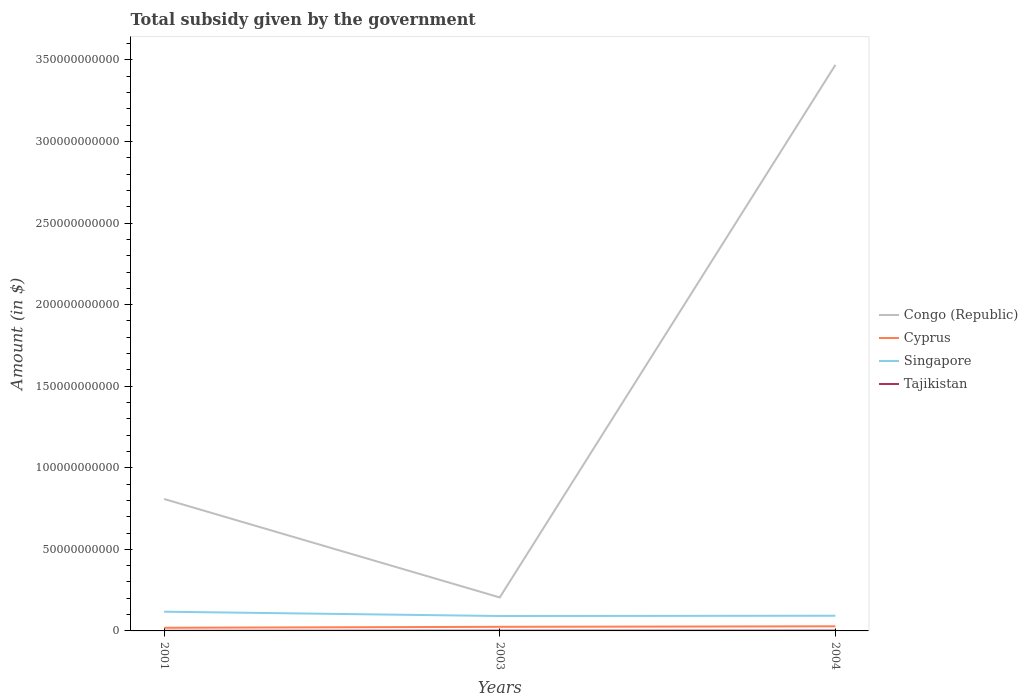How many different coloured lines are there?
Offer a terse response. 4. Does the line corresponding to Singapore intersect with the line corresponding to Tajikistan?
Your answer should be compact. No. Is the number of lines equal to the number of legend labels?
Ensure brevity in your answer.  Yes. Across all years, what is the maximum total revenue collected by the government in Congo (Republic)?
Give a very brief answer. 2.05e+1. In which year was the total revenue collected by the government in Singapore maximum?
Make the answer very short. 2003. What is the total total revenue collected by the government in Singapore in the graph?
Give a very brief answer. 2.47e+09. What is the difference between the highest and the second highest total revenue collected by the government in Cyprus?
Your response must be concise. 9.10e+08. How many lines are there?
Your response must be concise. 4. How many years are there in the graph?
Your answer should be compact. 3. What is the difference between two consecutive major ticks on the Y-axis?
Offer a very short reply. 5.00e+1. Are the values on the major ticks of Y-axis written in scientific E-notation?
Provide a succinct answer. No. Does the graph contain grids?
Ensure brevity in your answer.  No. How are the legend labels stacked?
Provide a short and direct response. Vertical. What is the title of the graph?
Your answer should be compact. Total subsidy given by the government. Does "Costa Rica" appear as one of the legend labels in the graph?
Your response must be concise. No. What is the label or title of the Y-axis?
Provide a succinct answer. Amount (in $). What is the Amount (in $) of Congo (Republic) in 2001?
Give a very brief answer. 8.09e+1. What is the Amount (in $) in Cyprus in 2001?
Keep it short and to the point. 1.92e+09. What is the Amount (in $) in Singapore in 2001?
Make the answer very short. 1.18e+1. What is the Amount (in $) in Tajikistan in 2001?
Give a very brief answer. 1.01e+08. What is the Amount (in $) of Congo (Republic) in 2003?
Offer a terse response. 2.05e+1. What is the Amount (in $) of Cyprus in 2003?
Make the answer very short. 2.52e+09. What is the Amount (in $) of Singapore in 2003?
Your answer should be compact. 9.13e+09. What is the Amount (in $) in Tajikistan in 2003?
Your answer should be very brief. 1.81e+08. What is the Amount (in $) of Congo (Republic) in 2004?
Offer a terse response. 3.47e+11. What is the Amount (in $) of Cyprus in 2004?
Your response must be concise. 2.83e+09. What is the Amount (in $) in Singapore in 2004?
Make the answer very short. 9.31e+09. What is the Amount (in $) in Tajikistan in 2004?
Give a very brief answer. 2.29e+08. Across all years, what is the maximum Amount (in $) in Congo (Republic)?
Provide a short and direct response. 3.47e+11. Across all years, what is the maximum Amount (in $) in Cyprus?
Your answer should be compact. 2.83e+09. Across all years, what is the maximum Amount (in $) of Singapore?
Make the answer very short. 1.18e+1. Across all years, what is the maximum Amount (in $) in Tajikistan?
Keep it short and to the point. 2.29e+08. Across all years, what is the minimum Amount (in $) in Congo (Republic)?
Your answer should be very brief. 2.05e+1. Across all years, what is the minimum Amount (in $) in Cyprus?
Your response must be concise. 1.92e+09. Across all years, what is the minimum Amount (in $) of Singapore?
Keep it short and to the point. 9.13e+09. Across all years, what is the minimum Amount (in $) in Tajikistan?
Provide a succinct answer. 1.01e+08. What is the total Amount (in $) in Congo (Republic) in the graph?
Keep it short and to the point. 4.48e+11. What is the total Amount (in $) in Cyprus in the graph?
Offer a very short reply. 7.28e+09. What is the total Amount (in $) of Singapore in the graph?
Give a very brief answer. 3.02e+1. What is the total Amount (in $) in Tajikistan in the graph?
Provide a succinct answer. 5.11e+08. What is the difference between the Amount (in $) of Congo (Republic) in 2001 and that in 2003?
Offer a very short reply. 6.04e+1. What is the difference between the Amount (in $) in Cyprus in 2001 and that in 2003?
Your answer should be compact. -5.96e+08. What is the difference between the Amount (in $) in Singapore in 2001 and that in 2003?
Your answer should be very brief. 2.65e+09. What is the difference between the Amount (in $) in Tajikistan in 2001 and that in 2003?
Your answer should be very brief. -8.01e+07. What is the difference between the Amount (in $) in Congo (Republic) in 2001 and that in 2004?
Give a very brief answer. -2.66e+11. What is the difference between the Amount (in $) of Cyprus in 2001 and that in 2004?
Provide a succinct answer. -9.10e+08. What is the difference between the Amount (in $) of Singapore in 2001 and that in 2004?
Give a very brief answer. 2.47e+09. What is the difference between the Amount (in $) of Tajikistan in 2001 and that in 2004?
Your answer should be compact. -1.28e+08. What is the difference between the Amount (in $) in Congo (Republic) in 2003 and that in 2004?
Provide a succinct answer. -3.26e+11. What is the difference between the Amount (in $) in Cyprus in 2003 and that in 2004?
Your answer should be very brief. -3.14e+08. What is the difference between the Amount (in $) in Singapore in 2003 and that in 2004?
Give a very brief answer. -1.80e+08. What is the difference between the Amount (in $) in Tajikistan in 2003 and that in 2004?
Offer a terse response. -4.79e+07. What is the difference between the Amount (in $) in Congo (Republic) in 2001 and the Amount (in $) in Cyprus in 2003?
Your response must be concise. 7.84e+1. What is the difference between the Amount (in $) of Congo (Republic) in 2001 and the Amount (in $) of Singapore in 2003?
Your response must be concise. 7.17e+1. What is the difference between the Amount (in $) in Congo (Republic) in 2001 and the Amount (in $) in Tajikistan in 2003?
Provide a short and direct response. 8.07e+1. What is the difference between the Amount (in $) in Cyprus in 2001 and the Amount (in $) in Singapore in 2003?
Keep it short and to the point. -7.21e+09. What is the difference between the Amount (in $) of Cyprus in 2001 and the Amount (in $) of Tajikistan in 2003?
Ensure brevity in your answer.  1.74e+09. What is the difference between the Amount (in $) of Singapore in 2001 and the Amount (in $) of Tajikistan in 2003?
Offer a terse response. 1.16e+1. What is the difference between the Amount (in $) in Congo (Republic) in 2001 and the Amount (in $) in Cyprus in 2004?
Offer a very short reply. 7.80e+1. What is the difference between the Amount (in $) in Congo (Republic) in 2001 and the Amount (in $) in Singapore in 2004?
Offer a terse response. 7.16e+1. What is the difference between the Amount (in $) of Congo (Republic) in 2001 and the Amount (in $) of Tajikistan in 2004?
Offer a terse response. 8.07e+1. What is the difference between the Amount (in $) in Cyprus in 2001 and the Amount (in $) in Singapore in 2004?
Keep it short and to the point. -7.39e+09. What is the difference between the Amount (in $) in Cyprus in 2001 and the Amount (in $) in Tajikistan in 2004?
Your response must be concise. 1.70e+09. What is the difference between the Amount (in $) in Singapore in 2001 and the Amount (in $) in Tajikistan in 2004?
Offer a terse response. 1.16e+1. What is the difference between the Amount (in $) of Congo (Republic) in 2003 and the Amount (in $) of Cyprus in 2004?
Keep it short and to the point. 1.77e+1. What is the difference between the Amount (in $) in Congo (Republic) in 2003 and the Amount (in $) in Singapore in 2004?
Make the answer very short. 1.12e+1. What is the difference between the Amount (in $) of Congo (Republic) in 2003 and the Amount (in $) of Tajikistan in 2004?
Your response must be concise. 2.03e+1. What is the difference between the Amount (in $) of Cyprus in 2003 and the Amount (in $) of Singapore in 2004?
Provide a succinct answer. -6.79e+09. What is the difference between the Amount (in $) in Cyprus in 2003 and the Amount (in $) in Tajikistan in 2004?
Give a very brief answer. 2.29e+09. What is the difference between the Amount (in $) of Singapore in 2003 and the Amount (in $) of Tajikistan in 2004?
Keep it short and to the point. 8.90e+09. What is the average Amount (in $) of Congo (Republic) per year?
Your response must be concise. 1.49e+11. What is the average Amount (in $) in Cyprus per year?
Provide a succinct answer. 2.43e+09. What is the average Amount (in $) in Singapore per year?
Your answer should be compact. 1.01e+1. What is the average Amount (in $) in Tajikistan per year?
Provide a short and direct response. 1.70e+08. In the year 2001, what is the difference between the Amount (in $) in Congo (Republic) and Amount (in $) in Cyprus?
Your answer should be very brief. 7.90e+1. In the year 2001, what is the difference between the Amount (in $) in Congo (Republic) and Amount (in $) in Singapore?
Provide a short and direct response. 6.91e+1. In the year 2001, what is the difference between the Amount (in $) in Congo (Republic) and Amount (in $) in Tajikistan?
Your answer should be very brief. 8.08e+1. In the year 2001, what is the difference between the Amount (in $) of Cyprus and Amount (in $) of Singapore?
Provide a short and direct response. -9.86e+09. In the year 2001, what is the difference between the Amount (in $) of Cyprus and Amount (in $) of Tajikistan?
Your answer should be very brief. 1.82e+09. In the year 2001, what is the difference between the Amount (in $) of Singapore and Amount (in $) of Tajikistan?
Ensure brevity in your answer.  1.17e+1. In the year 2003, what is the difference between the Amount (in $) in Congo (Republic) and Amount (in $) in Cyprus?
Make the answer very short. 1.80e+1. In the year 2003, what is the difference between the Amount (in $) of Congo (Republic) and Amount (in $) of Singapore?
Give a very brief answer. 1.14e+1. In the year 2003, what is the difference between the Amount (in $) of Congo (Republic) and Amount (in $) of Tajikistan?
Provide a short and direct response. 2.03e+1. In the year 2003, what is the difference between the Amount (in $) in Cyprus and Amount (in $) in Singapore?
Your answer should be compact. -6.61e+09. In the year 2003, what is the difference between the Amount (in $) in Cyprus and Amount (in $) in Tajikistan?
Ensure brevity in your answer.  2.34e+09. In the year 2003, what is the difference between the Amount (in $) of Singapore and Amount (in $) of Tajikistan?
Offer a very short reply. 8.95e+09. In the year 2004, what is the difference between the Amount (in $) in Congo (Republic) and Amount (in $) in Cyprus?
Your answer should be compact. 3.44e+11. In the year 2004, what is the difference between the Amount (in $) in Congo (Republic) and Amount (in $) in Singapore?
Your answer should be very brief. 3.38e+11. In the year 2004, what is the difference between the Amount (in $) of Congo (Republic) and Amount (in $) of Tajikistan?
Your response must be concise. 3.47e+11. In the year 2004, what is the difference between the Amount (in $) in Cyprus and Amount (in $) in Singapore?
Provide a short and direct response. -6.48e+09. In the year 2004, what is the difference between the Amount (in $) in Cyprus and Amount (in $) in Tajikistan?
Provide a short and direct response. 2.61e+09. In the year 2004, what is the difference between the Amount (in $) in Singapore and Amount (in $) in Tajikistan?
Give a very brief answer. 9.08e+09. What is the ratio of the Amount (in $) in Congo (Republic) in 2001 to that in 2003?
Provide a succinct answer. 3.94. What is the ratio of the Amount (in $) in Cyprus in 2001 to that in 2003?
Your answer should be compact. 0.76. What is the ratio of the Amount (in $) of Singapore in 2001 to that in 2003?
Offer a very short reply. 1.29. What is the ratio of the Amount (in $) of Tajikistan in 2001 to that in 2003?
Keep it short and to the point. 0.56. What is the ratio of the Amount (in $) in Congo (Republic) in 2001 to that in 2004?
Provide a succinct answer. 0.23. What is the ratio of the Amount (in $) of Cyprus in 2001 to that in 2004?
Offer a very short reply. 0.68. What is the ratio of the Amount (in $) in Singapore in 2001 to that in 2004?
Offer a terse response. 1.27. What is the ratio of the Amount (in $) in Tajikistan in 2001 to that in 2004?
Keep it short and to the point. 0.44. What is the ratio of the Amount (in $) in Congo (Republic) in 2003 to that in 2004?
Provide a short and direct response. 0.06. What is the ratio of the Amount (in $) in Cyprus in 2003 to that in 2004?
Your answer should be compact. 0.89. What is the ratio of the Amount (in $) in Singapore in 2003 to that in 2004?
Provide a succinct answer. 0.98. What is the ratio of the Amount (in $) in Tajikistan in 2003 to that in 2004?
Provide a succinct answer. 0.79. What is the difference between the highest and the second highest Amount (in $) of Congo (Republic)?
Give a very brief answer. 2.66e+11. What is the difference between the highest and the second highest Amount (in $) of Cyprus?
Your answer should be very brief. 3.14e+08. What is the difference between the highest and the second highest Amount (in $) in Singapore?
Provide a succinct answer. 2.47e+09. What is the difference between the highest and the second highest Amount (in $) in Tajikistan?
Offer a terse response. 4.79e+07. What is the difference between the highest and the lowest Amount (in $) of Congo (Republic)?
Offer a terse response. 3.26e+11. What is the difference between the highest and the lowest Amount (in $) in Cyprus?
Give a very brief answer. 9.10e+08. What is the difference between the highest and the lowest Amount (in $) of Singapore?
Your answer should be compact. 2.65e+09. What is the difference between the highest and the lowest Amount (in $) of Tajikistan?
Provide a short and direct response. 1.28e+08. 